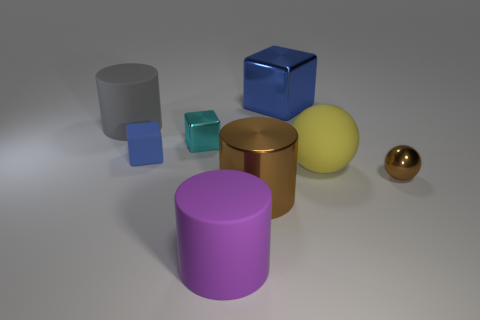Add 1 small brown cylinders. How many objects exist? 9 Subtract all cylinders. How many objects are left? 5 Add 3 yellow rubber spheres. How many yellow rubber spheres are left? 4 Add 2 small purple metal things. How many small purple metal things exist? 2 Subtract 0 purple blocks. How many objects are left? 8 Subtract all large blue rubber cylinders. Subtract all big yellow matte spheres. How many objects are left? 7 